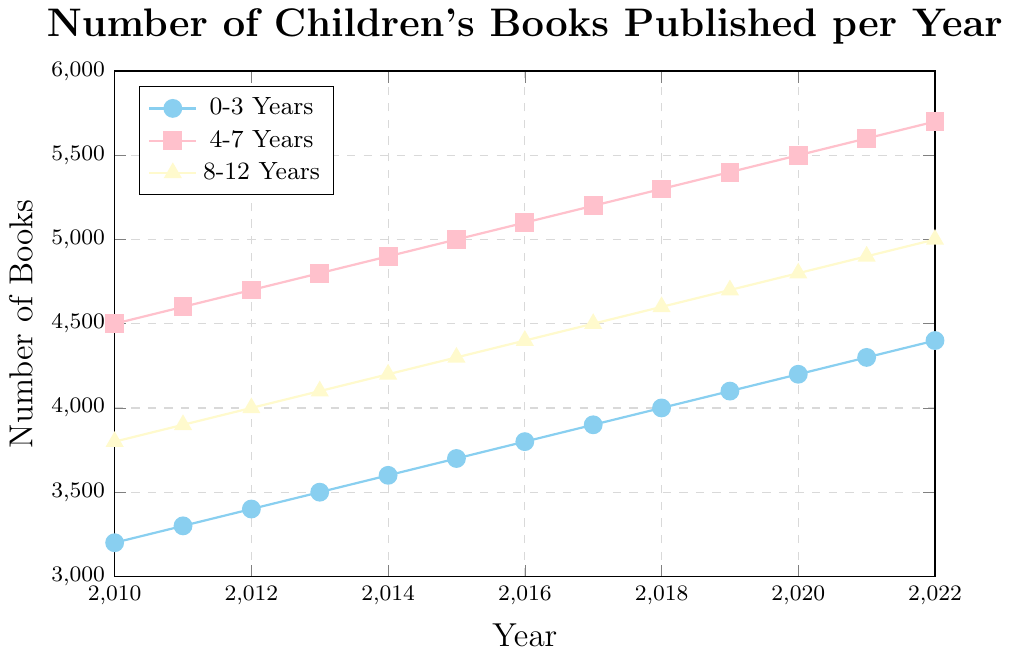what is the overall trend for the number of books published for all age groups from 2010 to 2022? The trend for the number of books published for each age group from 2010 to 2022 is overall increasing. All three age groups show a steady rise in the number of books published each year.
Answer: increasing what age group had the highest number of books published in 2015? In 2015, the plot shows that the age group 4-7 years had the highest number of books published, with 5,000 books.
Answer: 4-7 years which age group had the smallest increase in the number of books published between 2014 and 2018? The increase between 2014 and 2018 is calculated for each group as follows: 
0-3 years: 4000 - 3600 = 400 
4-7 years: 5300 - 4900 = 400 
8-12 years: 4600 - 4200 = 400 
Hence, all age groups had the same increase of 400 books during this period.
Answer: 0-3 years, 4-7 years, 8-12 years between which two consecutive years did the age group 0-3 years see the largest increase in the number of books published? We need to calculate the increase for each consecutive year for the 0-3 years age group. 
2011-2010: 3300 - 3200 = 100 
2012-2011: 3400 - 3300 = 100 
2013-2012: 3500 - 3400 = 100 
2014-2013: 3600 - 3500 = 100 
2015-2014: 3700 - 3600 = 100 
2016-2015: 3800 - 3700 = 100 
2017-2016: 3900 - 3800 = 100 
2018-2017: 4000 - 3900 = 100 
2019-2018: 4100 - 4000 = 100 
2020-2019: 4200 - 4100 = 100 
2021-2020: 4300 - 4200 = 100 
2022-2021: 4400 - 4300 = 100 
The largest increase is consistently 100 between all consecutive years.
Answer: 2011-2010 (and all consecutive years) by how many books did the number of books published for the 8-12 years age group increase from 2010 to 2022? To find the increase for the 8-12 age group from 2010 to 2022, we subtract the 2010 value from the 2022 value. 
5000 (2022) - 3800 (2010) = 1200
Answer: 1200 what is the most noticeable visual difference between the lines representing the 0-3 years and 4-7 years age groups? The line representing the 4-7 years age group is always higher on the y-axis compared to the 0-3 years age group line, indicating a consistently higher number of books published for the 4-7 years age group over the years. Also, the 4-7 line is represented with square markers, while the 0-3 line uses circular markers.
Answer: higher line and different markers which year saw the highest number of books published for the 4-7 years age group? The year with the highest number of books published for the 4-7 years age group is 2022 with 5700 books.
Answer: 2022 